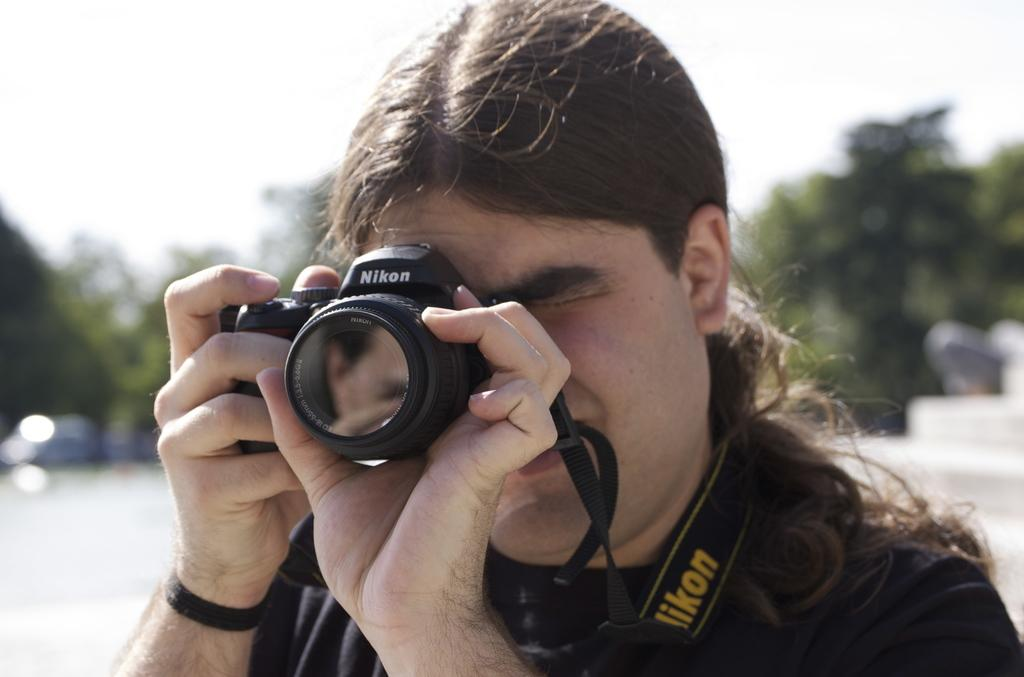What is the person in the image doing? The person is taking pictures. What is the person wearing in the image? The person is wearing a black dress. What is the person holding in the image? The person is holding a camera. What can be seen in the background of the image? There are trees and a vehicle on the road in the background of the image. What type of lip can be seen on the plate in the image? There is no plate or lip present in the image. What kind of bushes are growing near the trees in the background? The image does not provide information about bushes near the trees; only trees are mentioned in the background. 